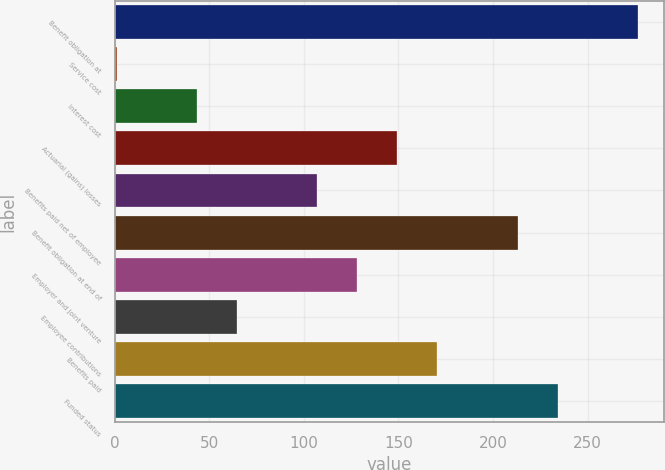<chart> <loc_0><loc_0><loc_500><loc_500><bar_chart><fcel>Benefit obligation at<fcel>Service cost<fcel>Interest cost<fcel>Actuarial (gains) losses<fcel>Benefits paid net of employee<fcel>Benefit obligation at end of<fcel>Employer and joint venture<fcel>Employee contributions<fcel>Benefits paid<fcel>Funded status<nl><fcel>276.6<fcel>1<fcel>43.4<fcel>149.4<fcel>107<fcel>213<fcel>128.2<fcel>64.6<fcel>170.6<fcel>234.2<nl></chart> 